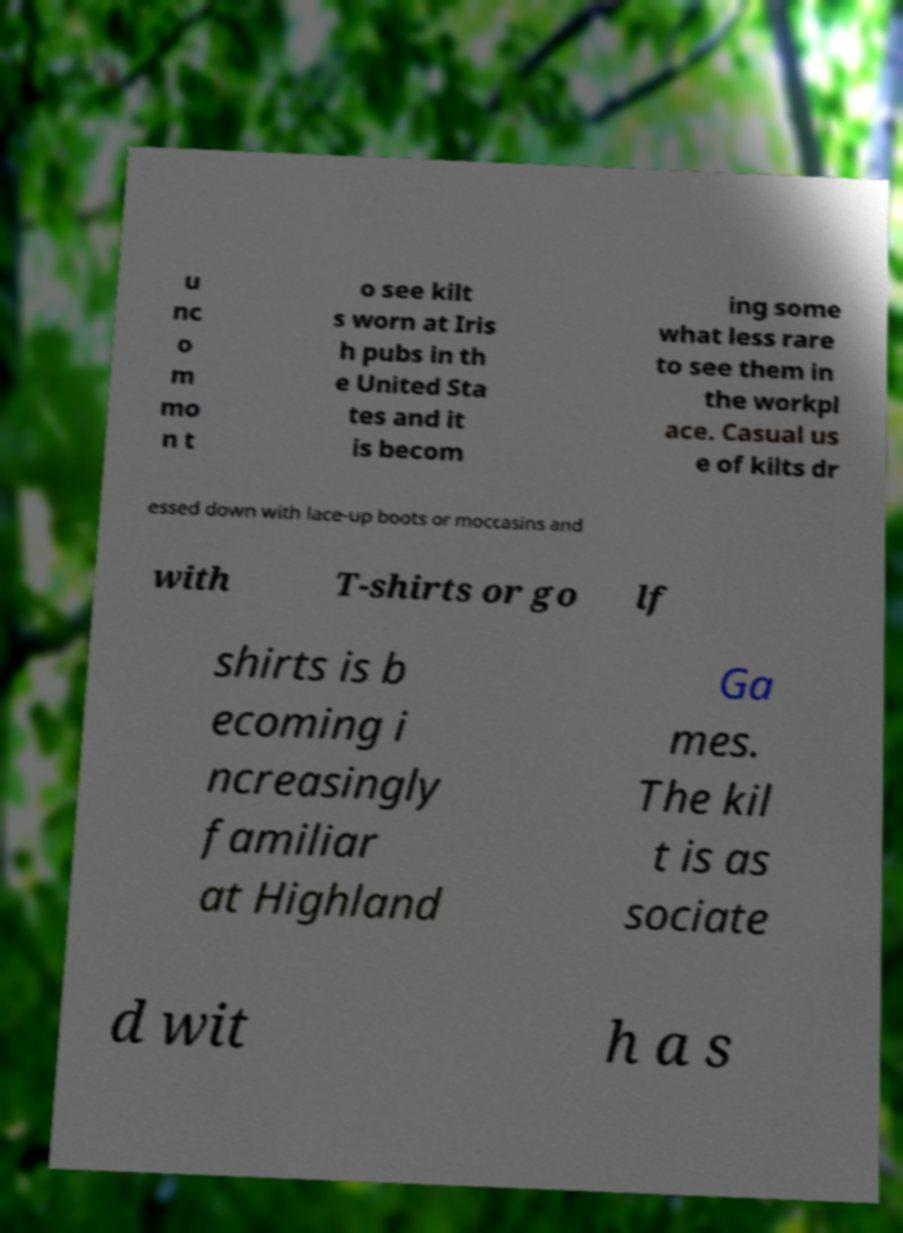I need the written content from this picture converted into text. Can you do that? u nc o m mo n t o see kilt s worn at Iris h pubs in th e United Sta tes and it is becom ing some what less rare to see them in the workpl ace. Casual us e of kilts dr essed down with lace-up boots or moccasins and with T-shirts or go lf shirts is b ecoming i ncreasingly familiar at Highland Ga mes. The kil t is as sociate d wit h a s 